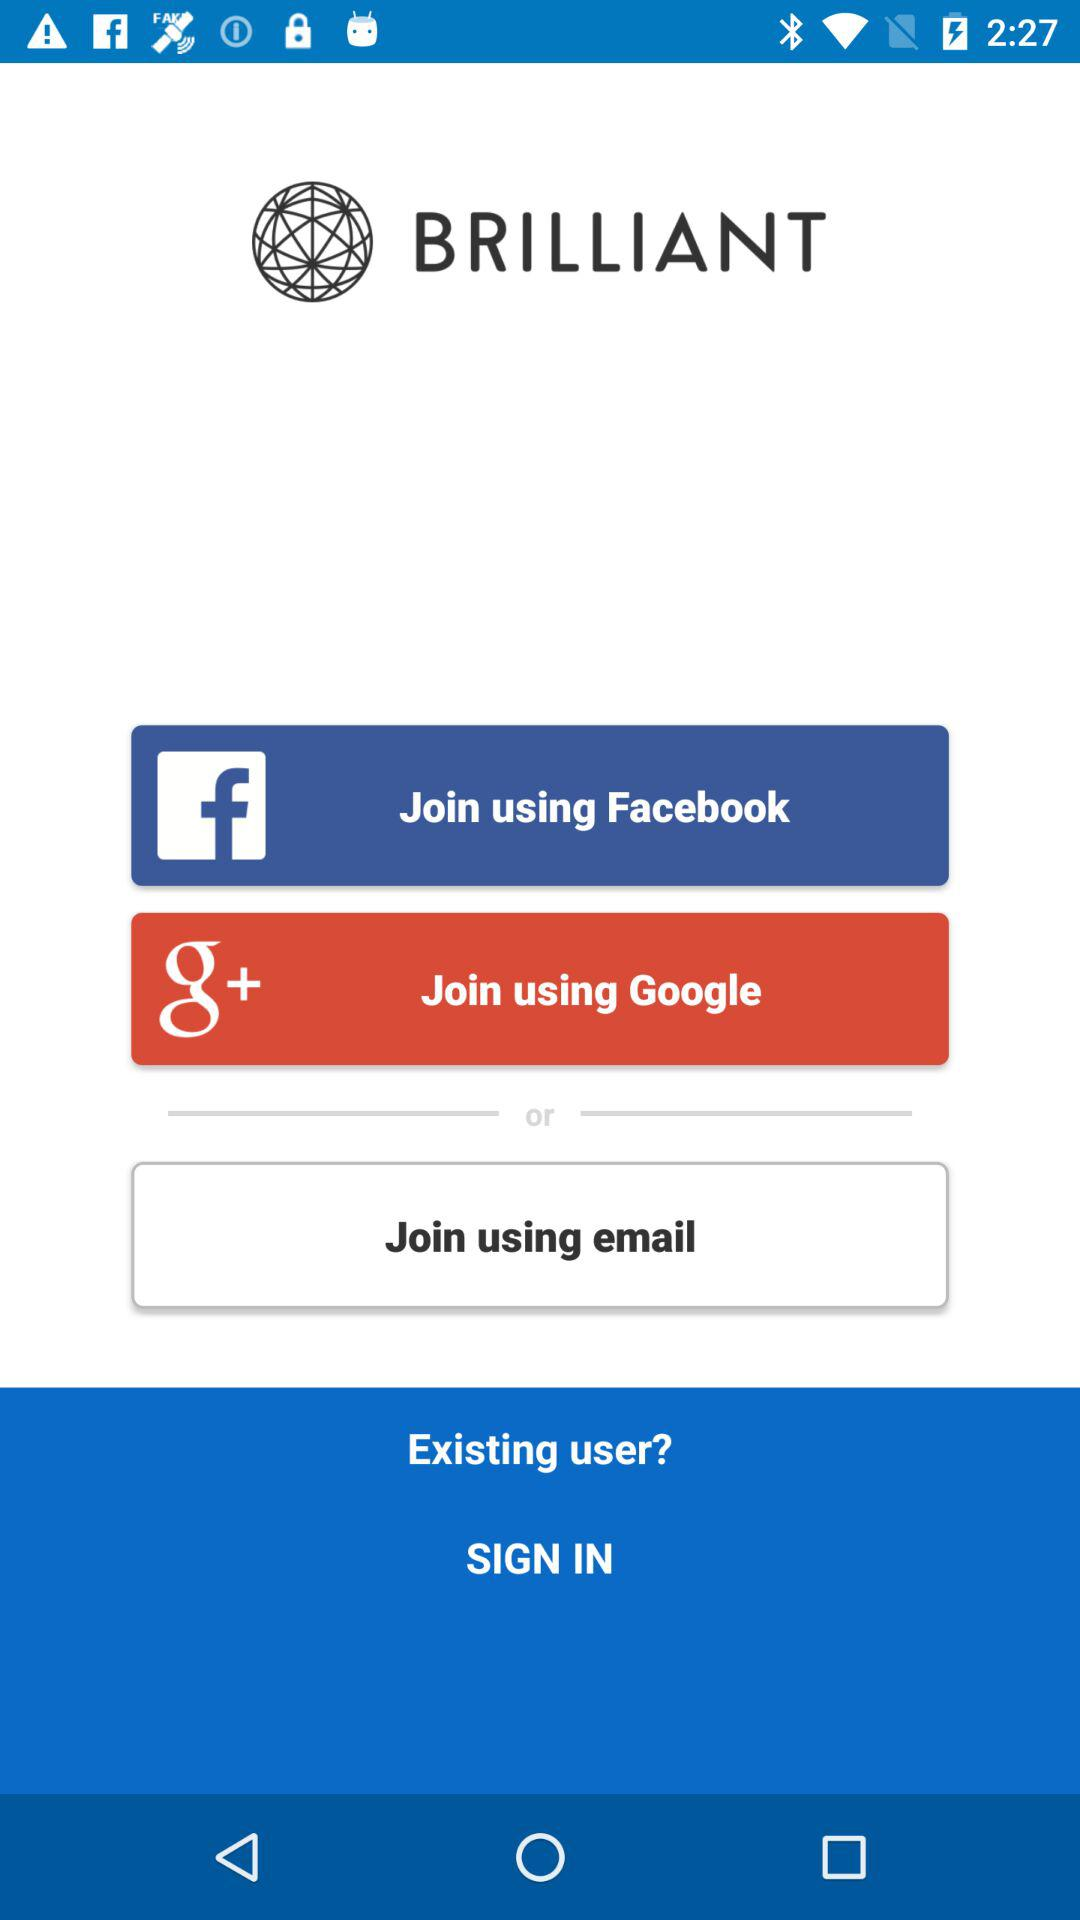How many sign in options are there?
Answer the question using a single word or phrase. 3 